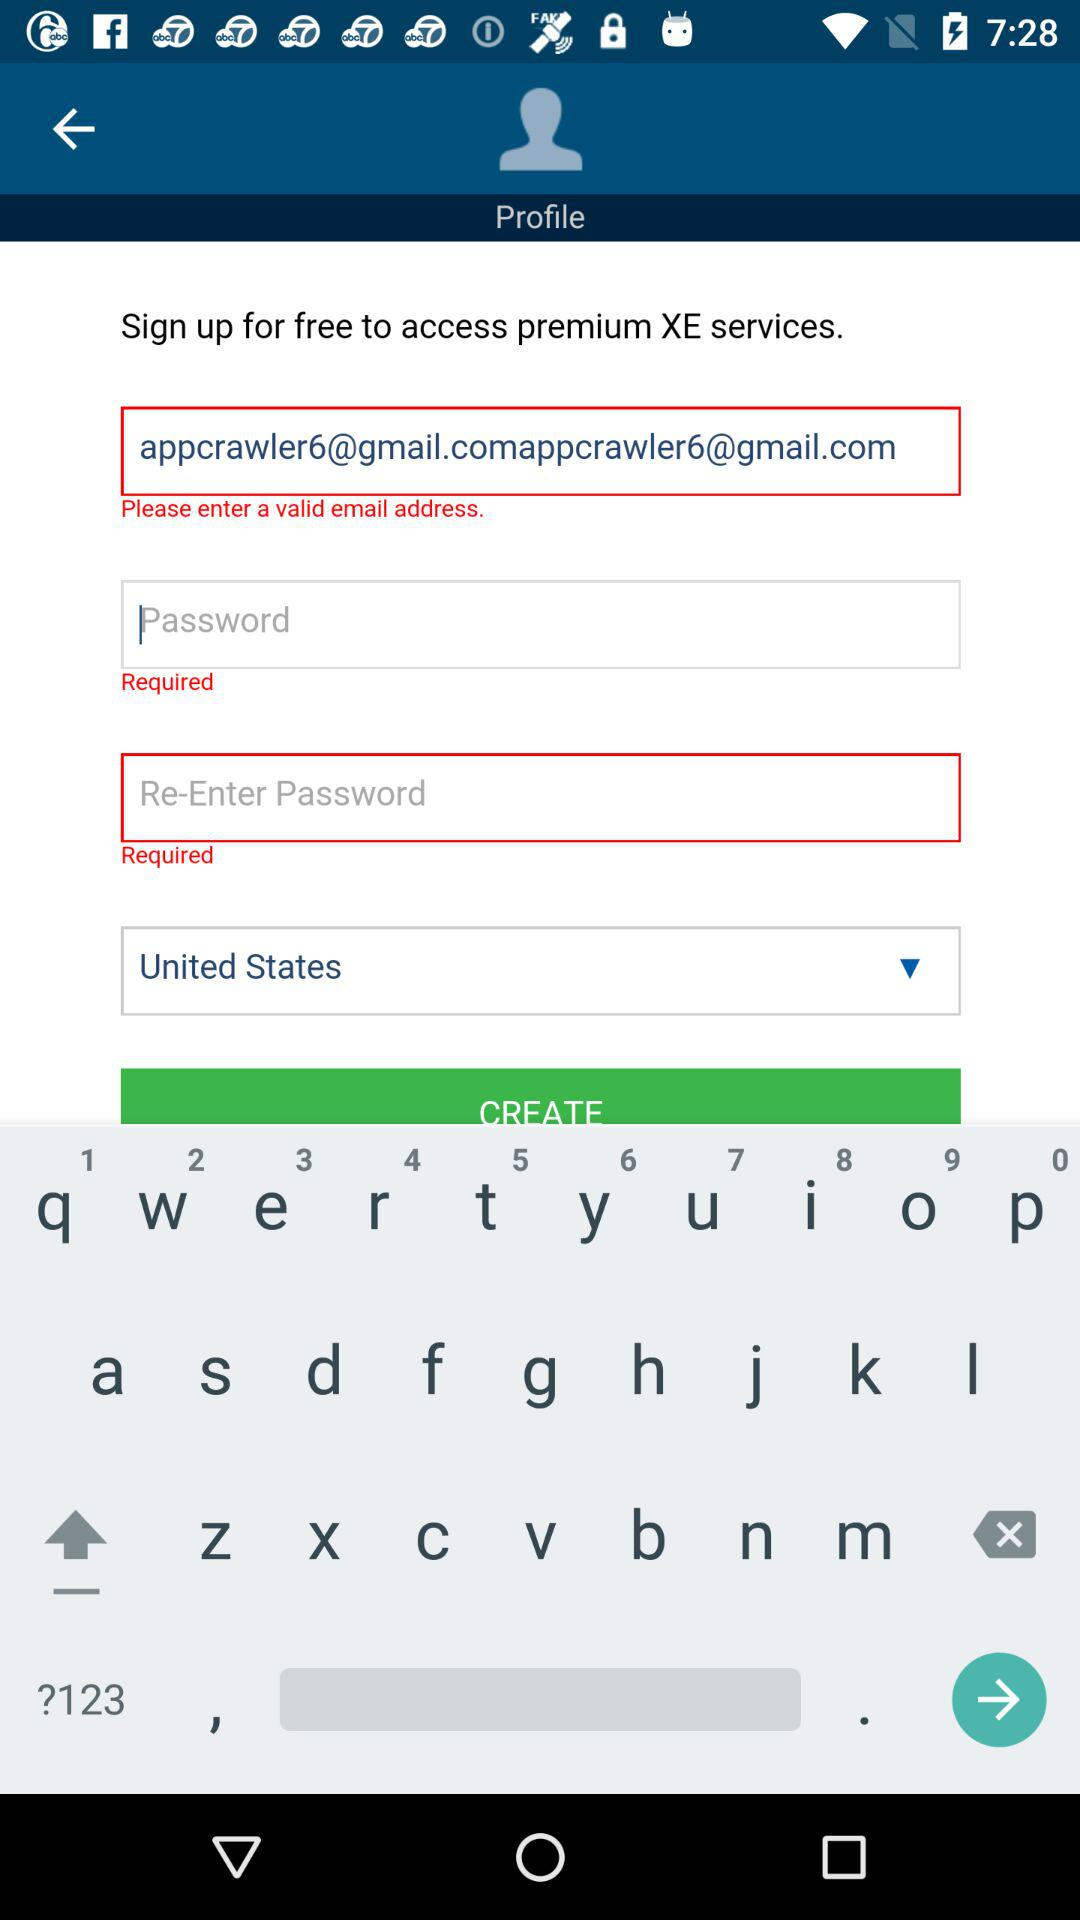How many text inputs are required to create an account?
Answer the question using a single word or phrase. 3 